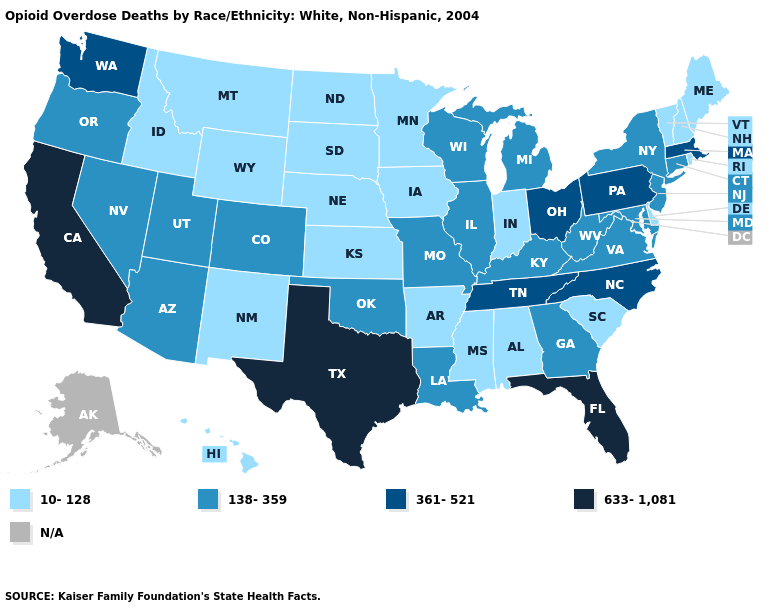Among the states that border Utah , does New Mexico have the highest value?
Short answer required. No. How many symbols are there in the legend?
Write a very short answer. 5. What is the lowest value in the USA?
Answer briefly. 10-128. Name the states that have a value in the range 138-359?
Give a very brief answer. Arizona, Colorado, Connecticut, Georgia, Illinois, Kentucky, Louisiana, Maryland, Michigan, Missouri, Nevada, New Jersey, New York, Oklahoma, Oregon, Utah, Virginia, West Virginia, Wisconsin. Does Texas have the highest value in the USA?
Keep it brief. Yes. What is the highest value in the MidWest ?
Answer briefly. 361-521. Among the states that border North Carolina , which have the highest value?
Keep it brief. Tennessee. What is the value of Kentucky?
Short answer required. 138-359. Does Massachusetts have the lowest value in the Northeast?
Give a very brief answer. No. Name the states that have a value in the range N/A?
Quick response, please. Alaska. What is the lowest value in the USA?
Short answer required. 10-128. What is the value of West Virginia?
Short answer required. 138-359. Which states have the highest value in the USA?
Write a very short answer. California, Florida, Texas. What is the value of Wisconsin?
Write a very short answer. 138-359. How many symbols are there in the legend?
Be succinct. 5. 